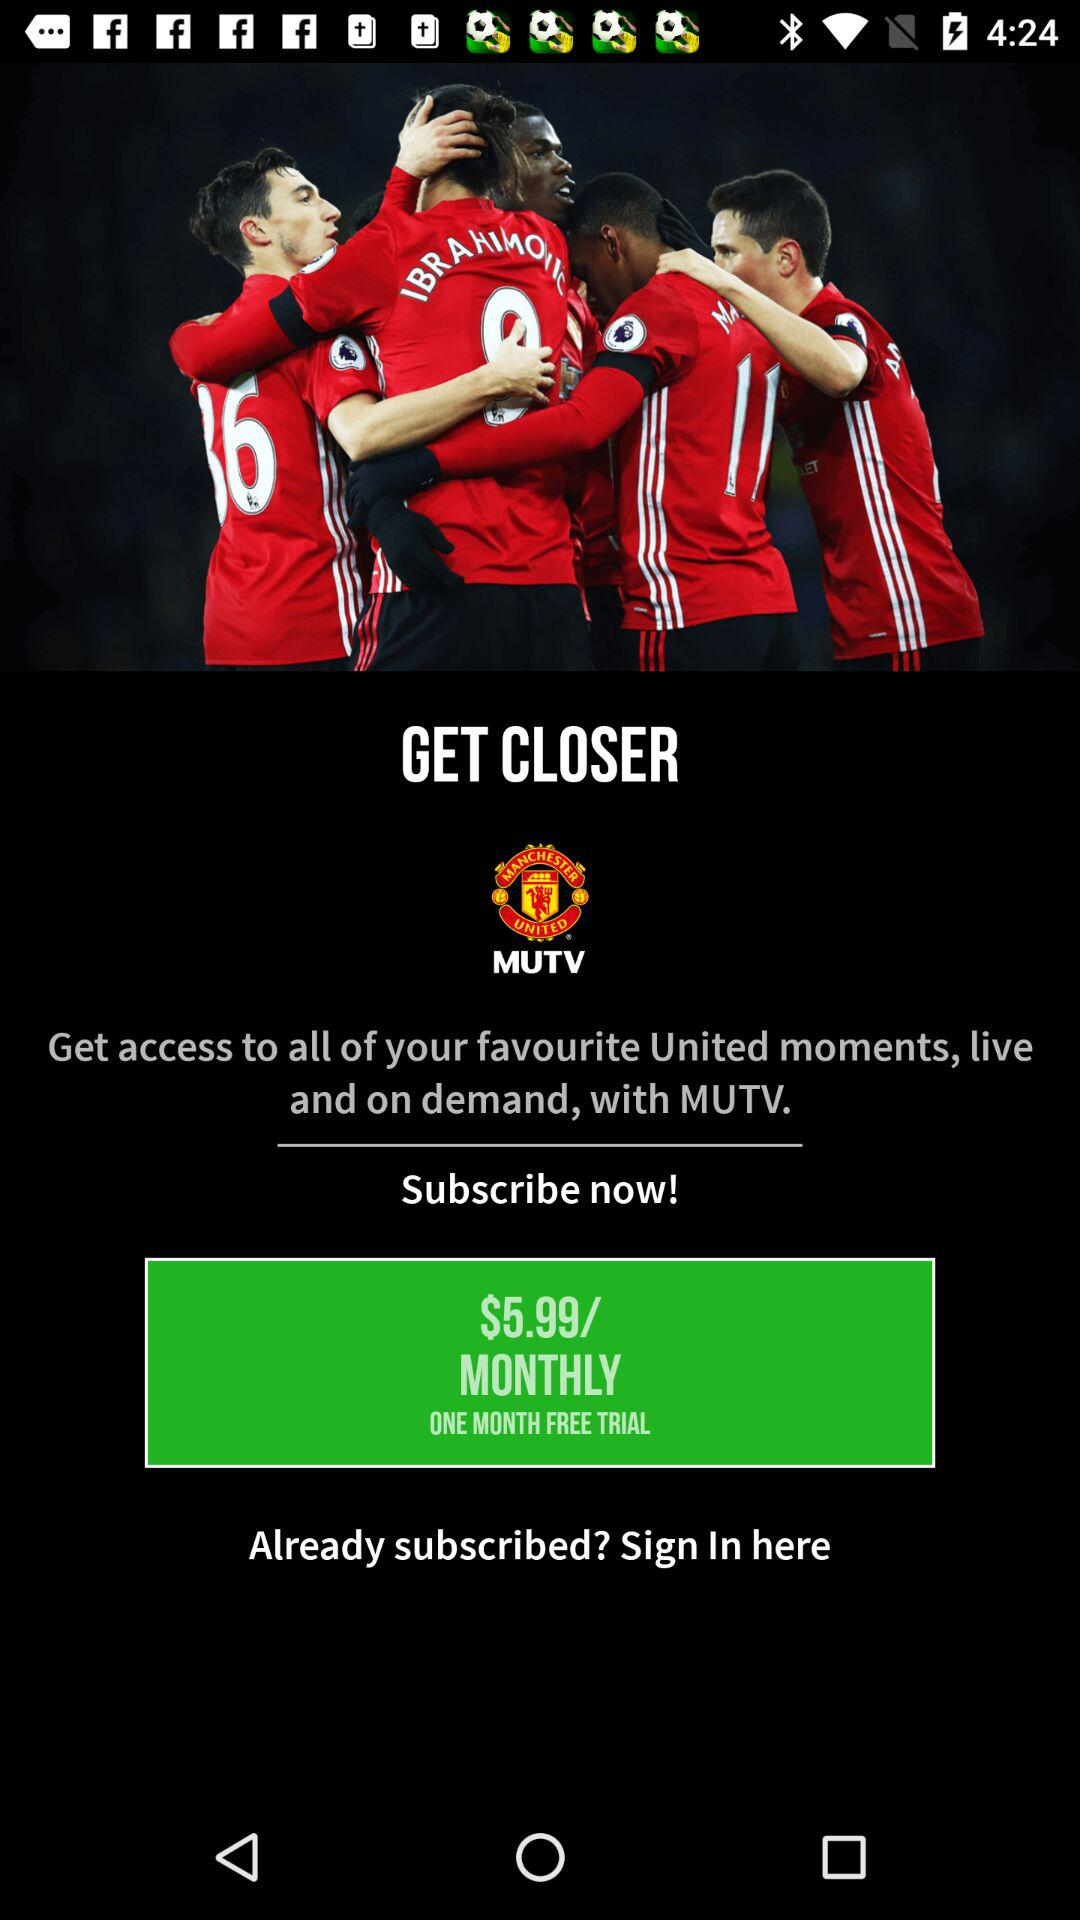How long is the free trial? The free trial is one month long. 